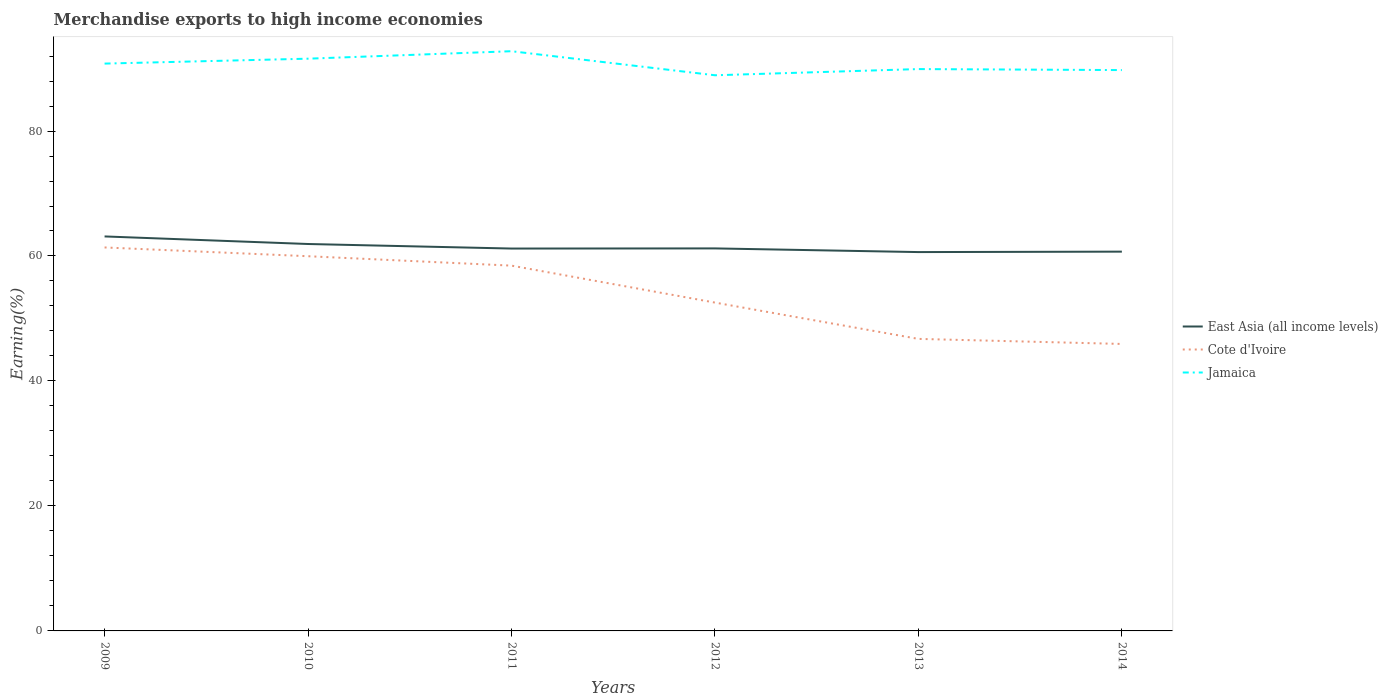How many different coloured lines are there?
Offer a terse response. 3. Across all years, what is the maximum percentage of amount earned from merchandise exports in Jamaica?
Provide a succinct answer. 88.92. What is the total percentage of amount earned from merchandise exports in Cote d'Ivoire in the graph?
Provide a succinct answer. 11.72. What is the difference between the highest and the second highest percentage of amount earned from merchandise exports in Jamaica?
Offer a terse response. 3.85. Is the percentage of amount earned from merchandise exports in Cote d'Ivoire strictly greater than the percentage of amount earned from merchandise exports in East Asia (all income levels) over the years?
Provide a short and direct response. Yes. Are the values on the major ticks of Y-axis written in scientific E-notation?
Give a very brief answer. No. Does the graph contain grids?
Ensure brevity in your answer.  No. Where does the legend appear in the graph?
Provide a short and direct response. Center right. How are the legend labels stacked?
Give a very brief answer. Vertical. What is the title of the graph?
Your answer should be compact. Merchandise exports to high income economies. What is the label or title of the X-axis?
Provide a succinct answer. Years. What is the label or title of the Y-axis?
Offer a terse response. Earning(%). What is the Earning(%) in East Asia (all income levels) in 2009?
Your answer should be compact. 63.13. What is the Earning(%) of Cote d'Ivoire in 2009?
Your answer should be compact. 61.37. What is the Earning(%) in Jamaica in 2009?
Offer a terse response. 90.79. What is the Earning(%) of East Asia (all income levels) in 2010?
Provide a short and direct response. 61.92. What is the Earning(%) in Cote d'Ivoire in 2010?
Make the answer very short. 59.96. What is the Earning(%) of Jamaica in 2010?
Offer a very short reply. 91.58. What is the Earning(%) of East Asia (all income levels) in 2011?
Your answer should be very brief. 61.19. What is the Earning(%) of Cote d'Ivoire in 2011?
Your response must be concise. 58.46. What is the Earning(%) in Jamaica in 2011?
Your response must be concise. 92.77. What is the Earning(%) in East Asia (all income levels) in 2012?
Offer a very short reply. 61.22. What is the Earning(%) of Cote d'Ivoire in 2012?
Ensure brevity in your answer.  52.54. What is the Earning(%) of Jamaica in 2012?
Your answer should be very brief. 88.92. What is the Earning(%) of East Asia (all income levels) in 2013?
Offer a very short reply. 60.63. What is the Earning(%) of Cote d'Ivoire in 2013?
Keep it short and to the point. 46.73. What is the Earning(%) of Jamaica in 2013?
Offer a very short reply. 89.91. What is the Earning(%) of East Asia (all income levels) in 2014?
Provide a short and direct response. 60.7. What is the Earning(%) in Cote d'Ivoire in 2014?
Make the answer very short. 45.93. What is the Earning(%) of Jamaica in 2014?
Provide a succinct answer. 89.75. Across all years, what is the maximum Earning(%) in East Asia (all income levels)?
Give a very brief answer. 63.13. Across all years, what is the maximum Earning(%) in Cote d'Ivoire?
Your answer should be compact. 61.37. Across all years, what is the maximum Earning(%) in Jamaica?
Offer a very short reply. 92.77. Across all years, what is the minimum Earning(%) in East Asia (all income levels)?
Your answer should be compact. 60.63. Across all years, what is the minimum Earning(%) of Cote d'Ivoire?
Keep it short and to the point. 45.93. Across all years, what is the minimum Earning(%) in Jamaica?
Your answer should be compact. 88.92. What is the total Earning(%) in East Asia (all income levels) in the graph?
Keep it short and to the point. 368.78. What is the total Earning(%) of Cote d'Ivoire in the graph?
Your answer should be very brief. 324.99. What is the total Earning(%) in Jamaica in the graph?
Ensure brevity in your answer.  543.72. What is the difference between the Earning(%) in East Asia (all income levels) in 2009 and that in 2010?
Give a very brief answer. 1.21. What is the difference between the Earning(%) in Cote d'Ivoire in 2009 and that in 2010?
Offer a very short reply. 1.4. What is the difference between the Earning(%) of Jamaica in 2009 and that in 2010?
Your answer should be very brief. -0.79. What is the difference between the Earning(%) in East Asia (all income levels) in 2009 and that in 2011?
Your answer should be compact. 1.94. What is the difference between the Earning(%) of Cote d'Ivoire in 2009 and that in 2011?
Provide a succinct answer. 2.91. What is the difference between the Earning(%) in Jamaica in 2009 and that in 2011?
Offer a very short reply. -1.98. What is the difference between the Earning(%) in East Asia (all income levels) in 2009 and that in 2012?
Make the answer very short. 1.92. What is the difference between the Earning(%) in Cote d'Ivoire in 2009 and that in 2012?
Ensure brevity in your answer.  8.82. What is the difference between the Earning(%) in Jamaica in 2009 and that in 2012?
Make the answer very short. 1.87. What is the difference between the Earning(%) in East Asia (all income levels) in 2009 and that in 2013?
Offer a very short reply. 2.5. What is the difference between the Earning(%) in Cote d'Ivoire in 2009 and that in 2013?
Offer a very short reply. 14.63. What is the difference between the Earning(%) in Jamaica in 2009 and that in 2013?
Provide a short and direct response. 0.88. What is the difference between the Earning(%) of East Asia (all income levels) in 2009 and that in 2014?
Your answer should be very brief. 2.43. What is the difference between the Earning(%) in Cote d'Ivoire in 2009 and that in 2014?
Your answer should be very brief. 15.44. What is the difference between the Earning(%) of Jamaica in 2009 and that in 2014?
Keep it short and to the point. 1.04. What is the difference between the Earning(%) in East Asia (all income levels) in 2010 and that in 2011?
Offer a very short reply. 0.73. What is the difference between the Earning(%) of Cote d'Ivoire in 2010 and that in 2011?
Offer a terse response. 1.51. What is the difference between the Earning(%) in Jamaica in 2010 and that in 2011?
Make the answer very short. -1.2. What is the difference between the Earning(%) in East Asia (all income levels) in 2010 and that in 2012?
Keep it short and to the point. 0.7. What is the difference between the Earning(%) of Cote d'Ivoire in 2010 and that in 2012?
Make the answer very short. 7.42. What is the difference between the Earning(%) of Jamaica in 2010 and that in 2012?
Keep it short and to the point. 2.65. What is the difference between the Earning(%) in East Asia (all income levels) in 2010 and that in 2013?
Your answer should be compact. 1.29. What is the difference between the Earning(%) in Cote d'Ivoire in 2010 and that in 2013?
Provide a succinct answer. 13.23. What is the difference between the Earning(%) of Jamaica in 2010 and that in 2013?
Keep it short and to the point. 1.66. What is the difference between the Earning(%) of East Asia (all income levels) in 2010 and that in 2014?
Your response must be concise. 1.22. What is the difference between the Earning(%) in Cote d'Ivoire in 2010 and that in 2014?
Your answer should be very brief. 14.04. What is the difference between the Earning(%) of Jamaica in 2010 and that in 2014?
Make the answer very short. 1.82. What is the difference between the Earning(%) of East Asia (all income levels) in 2011 and that in 2012?
Your answer should be compact. -0.02. What is the difference between the Earning(%) in Cote d'Ivoire in 2011 and that in 2012?
Your response must be concise. 5.91. What is the difference between the Earning(%) in Jamaica in 2011 and that in 2012?
Ensure brevity in your answer.  3.85. What is the difference between the Earning(%) in East Asia (all income levels) in 2011 and that in 2013?
Your answer should be compact. 0.56. What is the difference between the Earning(%) of Cote d'Ivoire in 2011 and that in 2013?
Your answer should be compact. 11.72. What is the difference between the Earning(%) of Jamaica in 2011 and that in 2013?
Your response must be concise. 2.86. What is the difference between the Earning(%) of East Asia (all income levels) in 2011 and that in 2014?
Keep it short and to the point. 0.49. What is the difference between the Earning(%) of Cote d'Ivoire in 2011 and that in 2014?
Ensure brevity in your answer.  12.53. What is the difference between the Earning(%) in Jamaica in 2011 and that in 2014?
Offer a terse response. 3.02. What is the difference between the Earning(%) of East Asia (all income levels) in 2012 and that in 2013?
Give a very brief answer. 0.59. What is the difference between the Earning(%) in Cote d'Ivoire in 2012 and that in 2013?
Your answer should be very brief. 5.81. What is the difference between the Earning(%) in Jamaica in 2012 and that in 2013?
Give a very brief answer. -0.99. What is the difference between the Earning(%) in East Asia (all income levels) in 2012 and that in 2014?
Your answer should be very brief. 0.52. What is the difference between the Earning(%) of Cote d'Ivoire in 2012 and that in 2014?
Make the answer very short. 6.62. What is the difference between the Earning(%) of Jamaica in 2012 and that in 2014?
Ensure brevity in your answer.  -0.83. What is the difference between the Earning(%) of East Asia (all income levels) in 2013 and that in 2014?
Ensure brevity in your answer.  -0.07. What is the difference between the Earning(%) in Cote d'Ivoire in 2013 and that in 2014?
Offer a very short reply. 0.81. What is the difference between the Earning(%) in Jamaica in 2013 and that in 2014?
Your answer should be compact. 0.16. What is the difference between the Earning(%) of East Asia (all income levels) in 2009 and the Earning(%) of Cote d'Ivoire in 2010?
Offer a very short reply. 3.17. What is the difference between the Earning(%) in East Asia (all income levels) in 2009 and the Earning(%) in Jamaica in 2010?
Offer a very short reply. -28.45. What is the difference between the Earning(%) of Cote d'Ivoire in 2009 and the Earning(%) of Jamaica in 2010?
Give a very brief answer. -30.21. What is the difference between the Earning(%) of East Asia (all income levels) in 2009 and the Earning(%) of Cote d'Ivoire in 2011?
Offer a terse response. 4.67. What is the difference between the Earning(%) of East Asia (all income levels) in 2009 and the Earning(%) of Jamaica in 2011?
Offer a terse response. -29.64. What is the difference between the Earning(%) in Cote d'Ivoire in 2009 and the Earning(%) in Jamaica in 2011?
Your response must be concise. -31.4. What is the difference between the Earning(%) of East Asia (all income levels) in 2009 and the Earning(%) of Cote d'Ivoire in 2012?
Your answer should be compact. 10.59. What is the difference between the Earning(%) in East Asia (all income levels) in 2009 and the Earning(%) in Jamaica in 2012?
Offer a very short reply. -25.79. What is the difference between the Earning(%) in Cote d'Ivoire in 2009 and the Earning(%) in Jamaica in 2012?
Give a very brief answer. -27.56. What is the difference between the Earning(%) of East Asia (all income levels) in 2009 and the Earning(%) of Cote d'Ivoire in 2013?
Offer a very short reply. 16.4. What is the difference between the Earning(%) of East Asia (all income levels) in 2009 and the Earning(%) of Jamaica in 2013?
Offer a very short reply. -26.78. What is the difference between the Earning(%) in Cote d'Ivoire in 2009 and the Earning(%) in Jamaica in 2013?
Your answer should be compact. -28.55. What is the difference between the Earning(%) of East Asia (all income levels) in 2009 and the Earning(%) of Cote d'Ivoire in 2014?
Offer a terse response. 17.21. What is the difference between the Earning(%) in East Asia (all income levels) in 2009 and the Earning(%) in Jamaica in 2014?
Give a very brief answer. -26.62. What is the difference between the Earning(%) in Cote d'Ivoire in 2009 and the Earning(%) in Jamaica in 2014?
Your answer should be very brief. -28.38. What is the difference between the Earning(%) of East Asia (all income levels) in 2010 and the Earning(%) of Cote d'Ivoire in 2011?
Keep it short and to the point. 3.46. What is the difference between the Earning(%) of East Asia (all income levels) in 2010 and the Earning(%) of Jamaica in 2011?
Give a very brief answer. -30.85. What is the difference between the Earning(%) in Cote d'Ivoire in 2010 and the Earning(%) in Jamaica in 2011?
Provide a succinct answer. -32.81. What is the difference between the Earning(%) in East Asia (all income levels) in 2010 and the Earning(%) in Cote d'Ivoire in 2012?
Your response must be concise. 9.38. What is the difference between the Earning(%) in East Asia (all income levels) in 2010 and the Earning(%) in Jamaica in 2012?
Your response must be concise. -27. What is the difference between the Earning(%) in Cote d'Ivoire in 2010 and the Earning(%) in Jamaica in 2012?
Keep it short and to the point. -28.96. What is the difference between the Earning(%) of East Asia (all income levels) in 2010 and the Earning(%) of Cote d'Ivoire in 2013?
Keep it short and to the point. 15.19. What is the difference between the Earning(%) of East Asia (all income levels) in 2010 and the Earning(%) of Jamaica in 2013?
Your answer should be compact. -27.99. What is the difference between the Earning(%) in Cote d'Ivoire in 2010 and the Earning(%) in Jamaica in 2013?
Your answer should be compact. -29.95. What is the difference between the Earning(%) of East Asia (all income levels) in 2010 and the Earning(%) of Cote d'Ivoire in 2014?
Make the answer very short. 15.99. What is the difference between the Earning(%) of East Asia (all income levels) in 2010 and the Earning(%) of Jamaica in 2014?
Provide a succinct answer. -27.83. What is the difference between the Earning(%) in Cote d'Ivoire in 2010 and the Earning(%) in Jamaica in 2014?
Give a very brief answer. -29.79. What is the difference between the Earning(%) in East Asia (all income levels) in 2011 and the Earning(%) in Cote d'Ivoire in 2012?
Offer a terse response. 8.65. What is the difference between the Earning(%) in East Asia (all income levels) in 2011 and the Earning(%) in Jamaica in 2012?
Provide a succinct answer. -27.73. What is the difference between the Earning(%) of Cote d'Ivoire in 2011 and the Earning(%) of Jamaica in 2012?
Give a very brief answer. -30.46. What is the difference between the Earning(%) of East Asia (all income levels) in 2011 and the Earning(%) of Cote d'Ivoire in 2013?
Your answer should be very brief. 14.46. What is the difference between the Earning(%) in East Asia (all income levels) in 2011 and the Earning(%) in Jamaica in 2013?
Your answer should be compact. -28.72. What is the difference between the Earning(%) in Cote d'Ivoire in 2011 and the Earning(%) in Jamaica in 2013?
Give a very brief answer. -31.45. What is the difference between the Earning(%) of East Asia (all income levels) in 2011 and the Earning(%) of Cote d'Ivoire in 2014?
Offer a terse response. 15.27. What is the difference between the Earning(%) of East Asia (all income levels) in 2011 and the Earning(%) of Jamaica in 2014?
Provide a succinct answer. -28.56. What is the difference between the Earning(%) of Cote d'Ivoire in 2011 and the Earning(%) of Jamaica in 2014?
Offer a very short reply. -31.29. What is the difference between the Earning(%) of East Asia (all income levels) in 2012 and the Earning(%) of Cote d'Ivoire in 2013?
Offer a terse response. 14.48. What is the difference between the Earning(%) in East Asia (all income levels) in 2012 and the Earning(%) in Jamaica in 2013?
Your answer should be compact. -28.7. What is the difference between the Earning(%) of Cote d'Ivoire in 2012 and the Earning(%) of Jamaica in 2013?
Keep it short and to the point. -37.37. What is the difference between the Earning(%) in East Asia (all income levels) in 2012 and the Earning(%) in Cote d'Ivoire in 2014?
Your answer should be very brief. 15.29. What is the difference between the Earning(%) in East Asia (all income levels) in 2012 and the Earning(%) in Jamaica in 2014?
Your answer should be compact. -28.54. What is the difference between the Earning(%) in Cote d'Ivoire in 2012 and the Earning(%) in Jamaica in 2014?
Give a very brief answer. -37.21. What is the difference between the Earning(%) in East Asia (all income levels) in 2013 and the Earning(%) in Cote d'Ivoire in 2014?
Offer a very short reply. 14.7. What is the difference between the Earning(%) in East Asia (all income levels) in 2013 and the Earning(%) in Jamaica in 2014?
Offer a very short reply. -29.13. What is the difference between the Earning(%) of Cote d'Ivoire in 2013 and the Earning(%) of Jamaica in 2014?
Make the answer very short. -43.02. What is the average Earning(%) of East Asia (all income levels) per year?
Your answer should be very brief. 61.46. What is the average Earning(%) of Cote d'Ivoire per year?
Offer a terse response. 54.17. What is the average Earning(%) of Jamaica per year?
Give a very brief answer. 90.62. In the year 2009, what is the difference between the Earning(%) of East Asia (all income levels) and Earning(%) of Cote d'Ivoire?
Your answer should be very brief. 1.76. In the year 2009, what is the difference between the Earning(%) in East Asia (all income levels) and Earning(%) in Jamaica?
Keep it short and to the point. -27.66. In the year 2009, what is the difference between the Earning(%) in Cote d'Ivoire and Earning(%) in Jamaica?
Your answer should be very brief. -29.42. In the year 2010, what is the difference between the Earning(%) in East Asia (all income levels) and Earning(%) in Cote d'Ivoire?
Offer a very short reply. 1.96. In the year 2010, what is the difference between the Earning(%) of East Asia (all income levels) and Earning(%) of Jamaica?
Provide a succinct answer. -29.66. In the year 2010, what is the difference between the Earning(%) in Cote d'Ivoire and Earning(%) in Jamaica?
Your answer should be compact. -31.61. In the year 2011, what is the difference between the Earning(%) of East Asia (all income levels) and Earning(%) of Cote d'Ivoire?
Your response must be concise. 2.73. In the year 2011, what is the difference between the Earning(%) in East Asia (all income levels) and Earning(%) in Jamaica?
Your response must be concise. -31.58. In the year 2011, what is the difference between the Earning(%) of Cote d'Ivoire and Earning(%) of Jamaica?
Provide a short and direct response. -34.31. In the year 2012, what is the difference between the Earning(%) of East Asia (all income levels) and Earning(%) of Cote d'Ivoire?
Your response must be concise. 8.67. In the year 2012, what is the difference between the Earning(%) in East Asia (all income levels) and Earning(%) in Jamaica?
Your answer should be very brief. -27.71. In the year 2012, what is the difference between the Earning(%) in Cote d'Ivoire and Earning(%) in Jamaica?
Make the answer very short. -36.38. In the year 2013, what is the difference between the Earning(%) in East Asia (all income levels) and Earning(%) in Cote d'Ivoire?
Provide a succinct answer. 13.89. In the year 2013, what is the difference between the Earning(%) in East Asia (all income levels) and Earning(%) in Jamaica?
Make the answer very short. -29.29. In the year 2013, what is the difference between the Earning(%) in Cote d'Ivoire and Earning(%) in Jamaica?
Your response must be concise. -43.18. In the year 2014, what is the difference between the Earning(%) of East Asia (all income levels) and Earning(%) of Cote d'Ivoire?
Provide a succinct answer. 14.77. In the year 2014, what is the difference between the Earning(%) of East Asia (all income levels) and Earning(%) of Jamaica?
Ensure brevity in your answer.  -29.06. In the year 2014, what is the difference between the Earning(%) of Cote d'Ivoire and Earning(%) of Jamaica?
Provide a short and direct response. -43.83. What is the ratio of the Earning(%) of East Asia (all income levels) in 2009 to that in 2010?
Give a very brief answer. 1.02. What is the ratio of the Earning(%) in Cote d'Ivoire in 2009 to that in 2010?
Keep it short and to the point. 1.02. What is the ratio of the Earning(%) of East Asia (all income levels) in 2009 to that in 2011?
Your answer should be compact. 1.03. What is the ratio of the Earning(%) of Cote d'Ivoire in 2009 to that in 2011?
Make the answer very short. 1.05. What is the ratio of the Earning(%) in Jamaica in 2009 to that in 2011?
Provide a short and direct response. 0.98. What is the ratio of the Earning(%) of East Asia (all income levels) in 2009 to that in 2012?
Provide a short and direct response. 1.03. What is the ratio of the Earning(%) of Cote d'Ivoire in 2009 to that in 2012?
Your response must be concise. 1.17. What is the ratio of the Earning(%) of Jamaica in 2009 to that in 2012?
Make the answer very short. 1.02. What is the ratio of the Earning(%) of East Asia (all income levels) in 2009 to that in 2013?
Provide a short and direct response. 1.04. What is the ratio of the Earning(%) of Cote d'Ivoire in 2009 to that in 2013?
Give a very brief answer. 1.31. What is the ratio of the Earning(%) in Jamaica in 2009 to that in 2013?
Make the answer very short. 1.01. What is the ratio of the Earning(%) of East Asia (all income levels) in 2009 to that in 2014?
Provide a succinct answer. 1.04. What is the ratio of the Earning(%) in Cote d'Ivoire in 2009 to that in 2014?
Provide a short and direct response. 1.34. What is the ratio of the Earning(%) of Jamaica in 2009 to that in 2014?
Your response must be concise. 1.01. What is the ratio of the Earning(%) of East Asia (all income levels) in 2010 to that in 2011?
Give a very brief answer. 1.01. What is the ratio of the Earning(%) of Cote d'Ivoire in 2010 to that in 2011?
Provide a short and direct response. 1.03. What is the ratio of the Earning(%) in Jamaica in 2010 to that in 2011?
Keep it short and to the point. 0.99. What is the ratio of the Earning(%) of East Asia (all income levels) in 2010 to that in 2012?
Ensure brevity in your answer.  1.01. What is the ratio of the Earning(%) of Cote d'Ivoire in 2010 to that in 2012?
Provide a succinct answer. 1.14. What is the ratio of the Earning(%) of Jamaica in 2010 to that in 2012?
Provide a succinct answer. 1.03. What is the ratio of the Earning(%) in East Asia (all income levels) in 2010 to that in 2013?
Your response must be concise. 1.02. What is the ratio of the Earning(%) of Cote d'Ivoire in 2010 to that in 2013?
Offer a very short reply. 1.28. What is the ratio of the Earning(%) of Jamaica in 2010 to that in 2013?
Provide a succinct answer. 1.02. What is the ratio of the Earning(%) of East Asia (all income levels) in 2010 to that in 2014?
Your answer should be compact. 1.02. What is the ratio of the Earning(%) in Cote d'Ivoire in 2010 to that in 2014?
Your answer should be compact. 1.31. What is the ratio of the Earning(%) in Jamaica in 2010 to that in 2014?
Give a very brief answer. 1.02. What is the ratio of the Earning(%) of Cote d'Ivoire in 2011 to that in 2012?
Ensure brevity in your answer.  1.11. What is the ratio of the Earning(%) of Jamaica in 2011 to that in 2012?
Ensure brevity in your answer.  1.04. What is the ratio of the Earning(%) of East Asia (all income levels) in 2011 to that in 2013?
Your response must be concise. 1.01. What is the ratio of the Earning(%) in Cote d'Ivoire in 2011 to that in 2013?
Ensure brevity in your answer.  1.25. What is the ratio of the Earning(%) in Jamaica in 2011 to that in 2013?
Ensure brevity in your answer.  1.03. What is the ratio of the Earning(%) of Cote d'Ivoire in 2011 to that in 2014?
Your answer should be very brief. 1.27. What is the ratio of the Earning(%) in Jamaica in 2011 to that in 2014?
Provide a short and direct response. 1.03. What is the ratio of the Earning(%) of East Asia (all income levels) in 2012 to that in 2013?
Offer a very short reply. 1.01. What is the ratio of the Earning(%) of Cote d'Ivoire in 2012 to that in 2013?
Give a very brief answer. 1.12. What is the ratio of the Earning(%) of Jamaica in 2012 to that in 2013?
Offer a terse response. 0.99. What is the ratio of the Earning(%) of East Asia (all income levels) in 2012 to that in 2014?
Your response must be concise. 1.01. What is the ratio of the Earning(%) of Cote d'Ivoire in 2012 to that in 2014?
Keep it short and to the point. 1.14. What is the ratio of the Earning(%) in Jamaica in 2012 to that in 2014?
Provide a short and direct response. 0.99. What is the ratio of the Earning(%) in East Asia (all income levels) in 2013 to that in 2014?
Ensure brevity in your answer.  1. What is the ratio of the Earning(%) of Cote d'Ivoire in 2013 to that in 2014?
Your response must be concise. 1.02. What is the difference between the highest and the second highest Earning(%) of East Asia (all income levels)?
Give a very brief answer. 1.21. What is the difference between the highest and the second highest Earning(%) of Cote d'Ivoire?
Provide a short and direct response. 1.4. What is the difference between the highest and the second highest Earning(%) in Jamaica?
Offer a very short reply. 1.2. What is the difference between the highest and the lowest Earning(%) in East Asia (all income levels)?
Give a very brief answer. 2.5. What is the difference between the highest and the lowest Earning(%) of Cote d'Ivoire?
Make the answer very short. 15.44. What is the difference between the highest and the lowest Earning(%) of Jamaica?
Offer a very short reply. 3.85. 